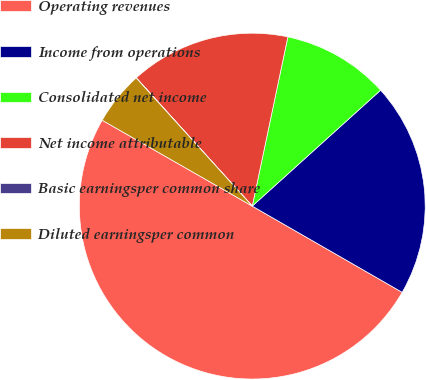Convert chart. <chart><loc_0><loc_0><loc_500><loc_500><pie_chart><fcel>Operating revenues<fcel>Income from operations<fcel>Consolidated net income<fcel>Net income attributable<fcel>Basic earningsper common share<fcel>Diluted earningsper common<nl><fcel>49.97%<fcel>20.0%<fcel>10.01%<fcel>15.0%<fcel>0.02%<fcel>5.01%<nl></chart> 